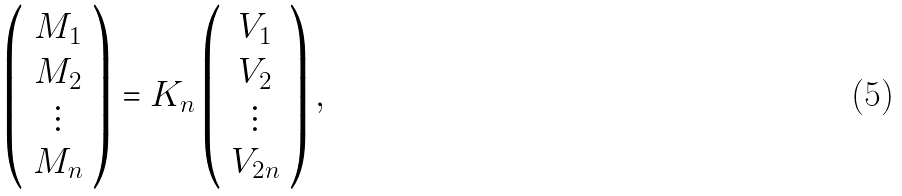Convert formula to latex. <formula><loc_0><loc_0><loc_500><loc_500>\left ( \begin{array} { c } M _ { 1 } \\ M _ { 2 } \\ \vdots \\ M _ { n } \end{array} \right ) = K _ { n } \left ( \begin{array} { c } V _ { 1 } \\ V _ { 2 } \\ \vdots \\ V _ { 2 n } \end{array} \right ) ,</formula> 